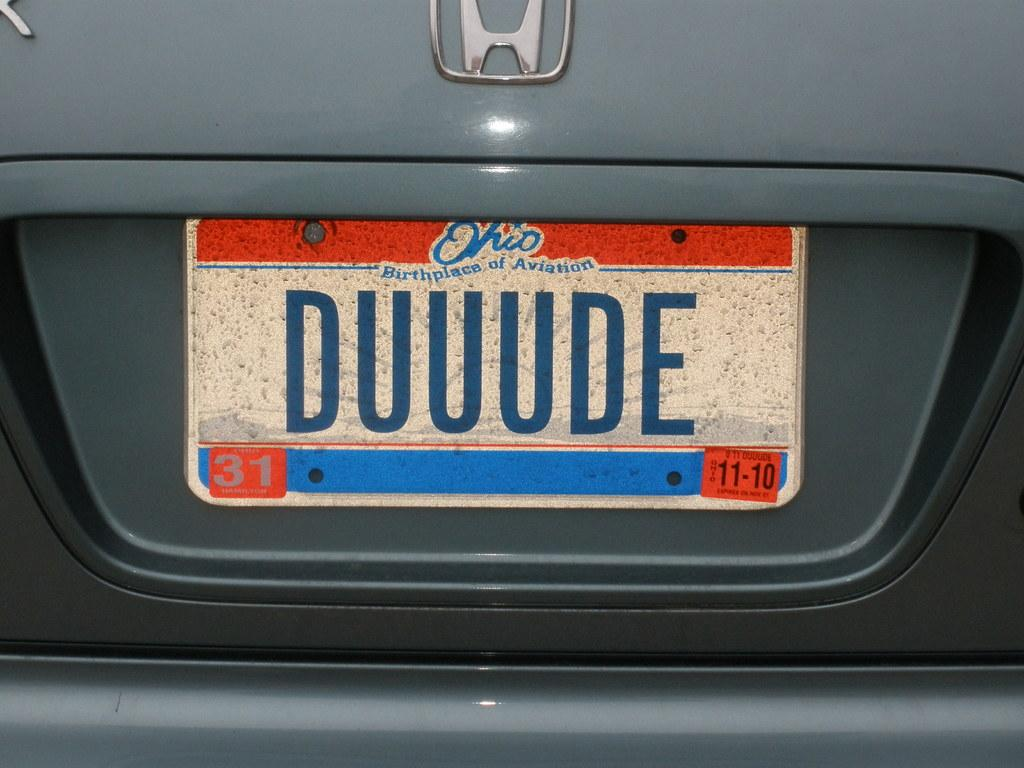Provide a one-sentence caption for the provided image. A license plate on a car of someone who moved to Ohio from the L.A. valley. 